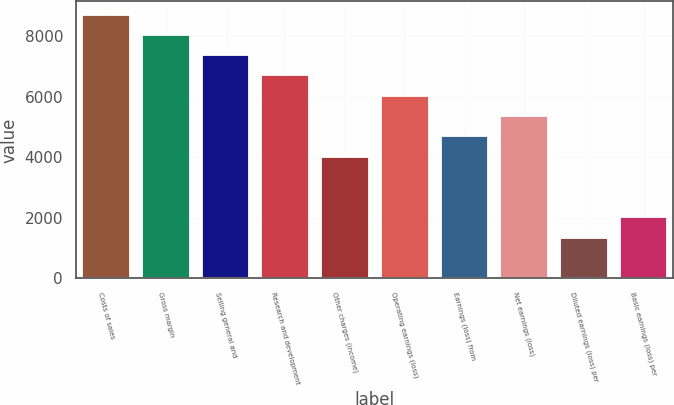Convert chart. <chart><loc_0><loc_0><loc_500><loc_500><bar_chart><fcel>Costs of sales<fcel>Gross margin<fcel>Selling general and<fcel>Research and development<fcel>Other charges (income)<fcel>Operating earnings (loss)<fcel>Earnings (loss) from<fcel>Net earnings (loss)<fcel>Diluted earnings (loss) per<fcel>Basic earnings (loss) per<nl><fcel>8711.34<fcel>8041.24<fcel>7371.14<fcel>6701.04<fcel>4020.64<fcel>6030.94<fcel>4690.74<fcel>5360.84<fcel>1340.24<fcel>2010.34<nl></chart> 